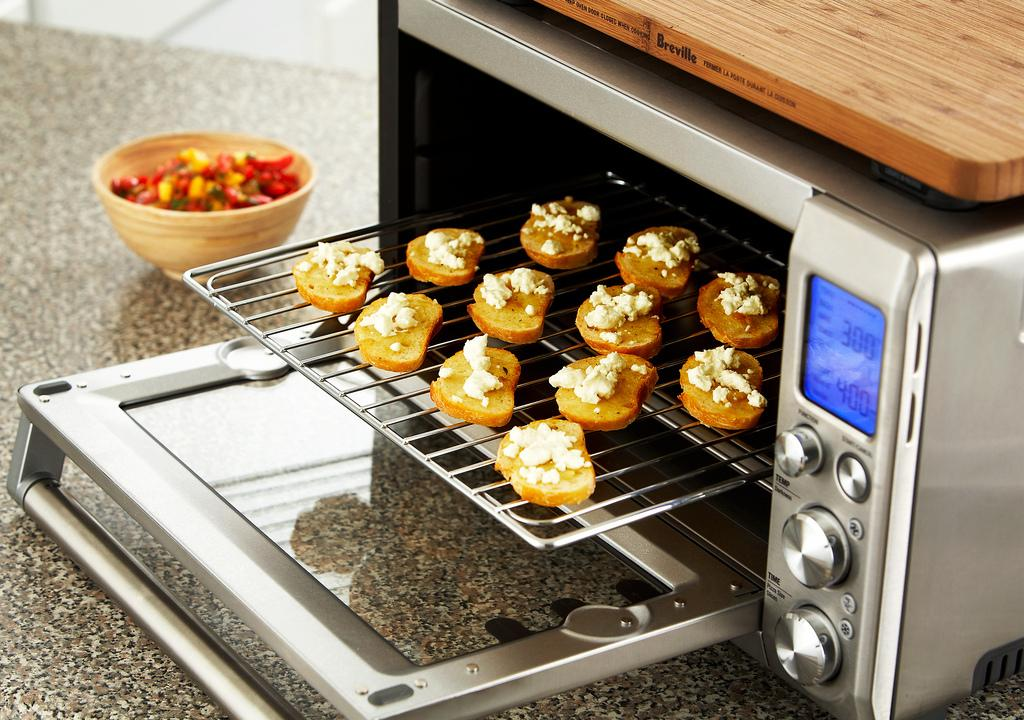<image>
Provide a brief description of the given image. Items about to get baked in the oven at 300 degrees. 